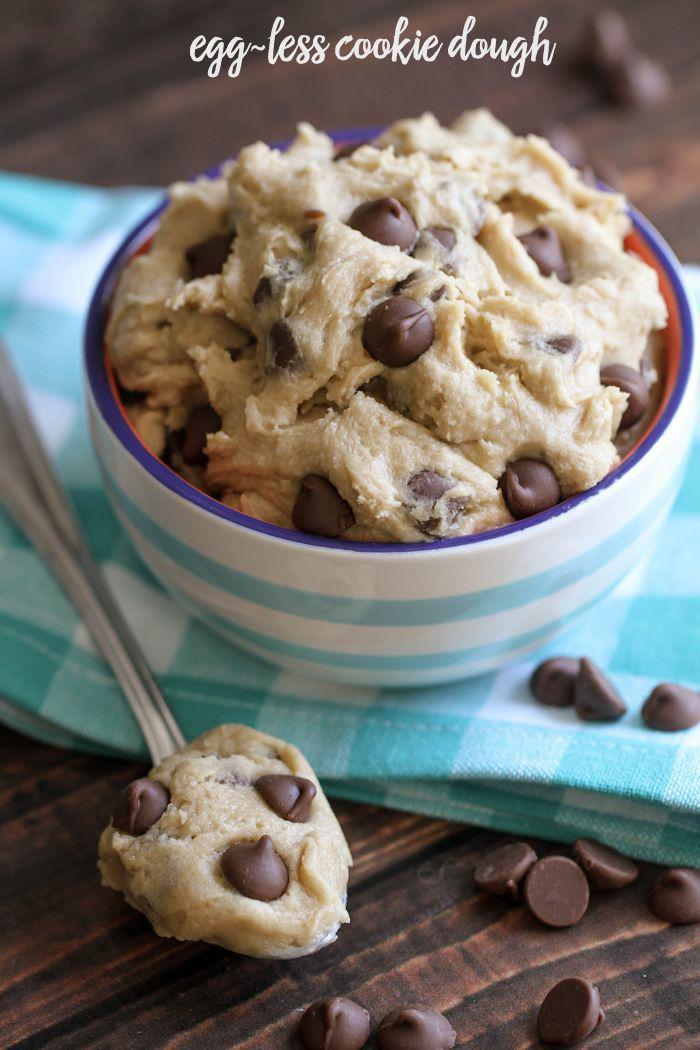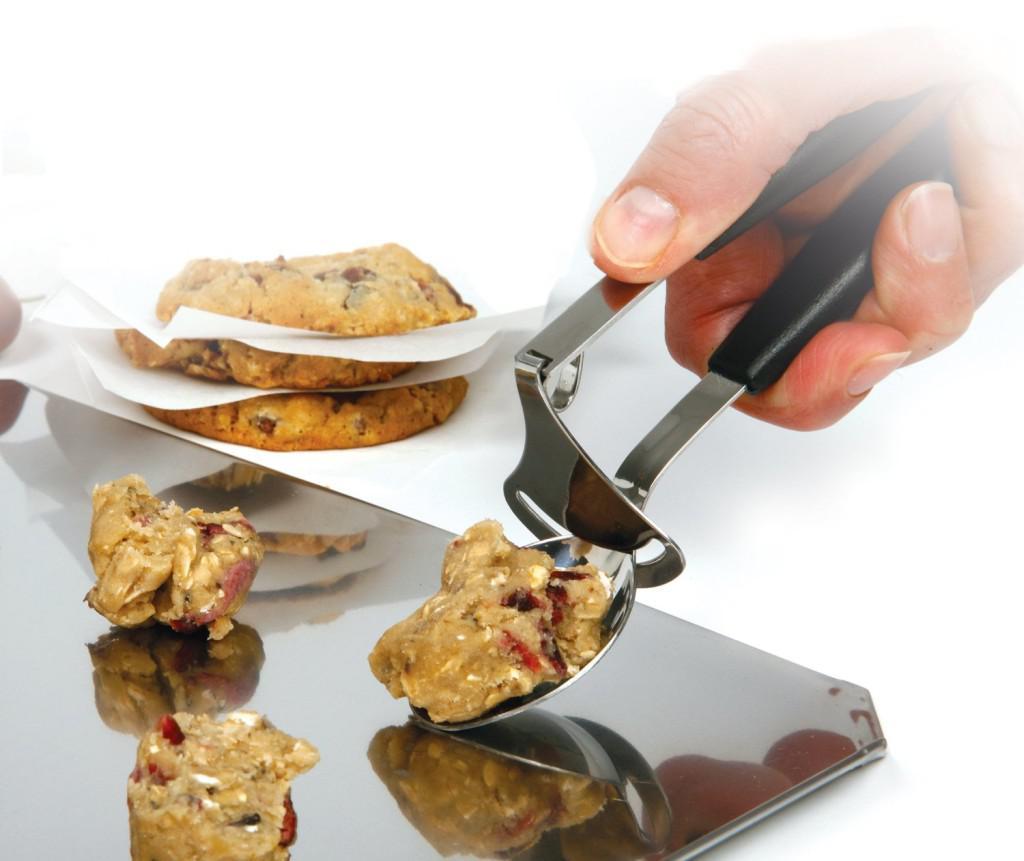The first image is the image on the left, the second image is the image on the right. Examine the images to the left and right. Is the description "Each image includes raw cookie dough, and at least one image includes raw cookie dough in a round bowl and a spoon with cookie dough on it." accurate? Answer yes or no. Yes. The first image is the image on the left, the second image is the image on the right. Considering the images on both sides, is "There is at least one human hand visible here." valid? Answer yes or no. Yes. 